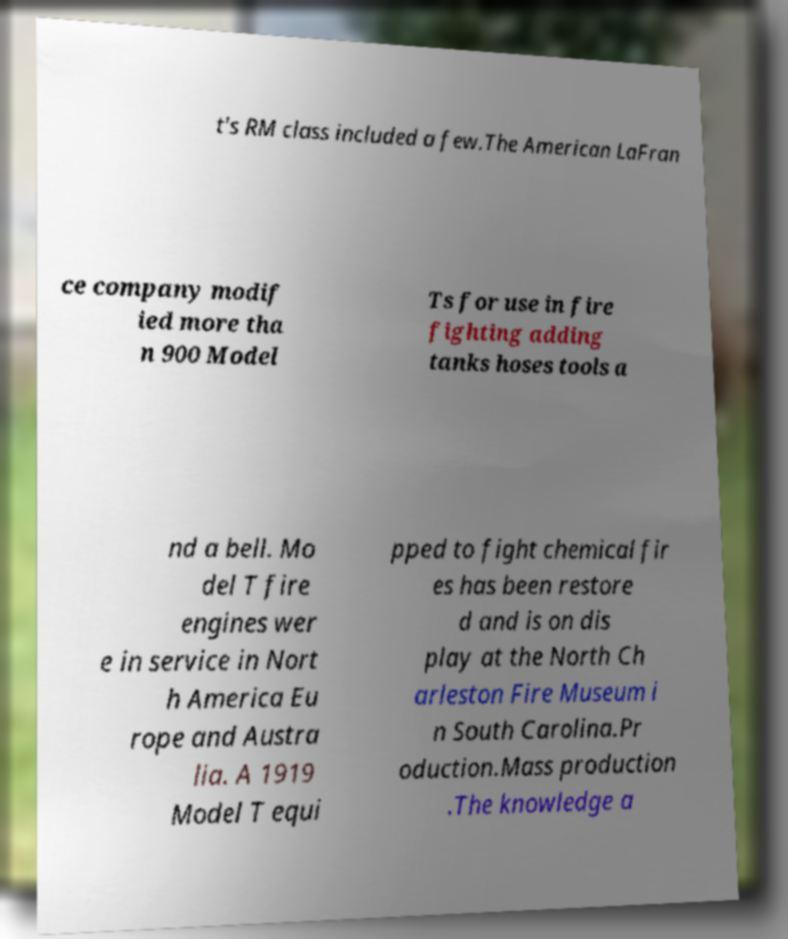Please identify and transcribe the text found in this image. t's RM class included a few.The American LaFran ce company modif ied more tha n 900 Model Ts for use in fire fighting adding tanks hoses tools a nd a bell. Mo del T fire engines wer e in service in Nort h America Eu rope and Austra lia. A 1919 Model T equi pped to fight chemical fir es has been restore d and is on dis play at the North Ch arleston Fire Museum i n South Carolina.Pr oduction.Mass production .The knowledge a 